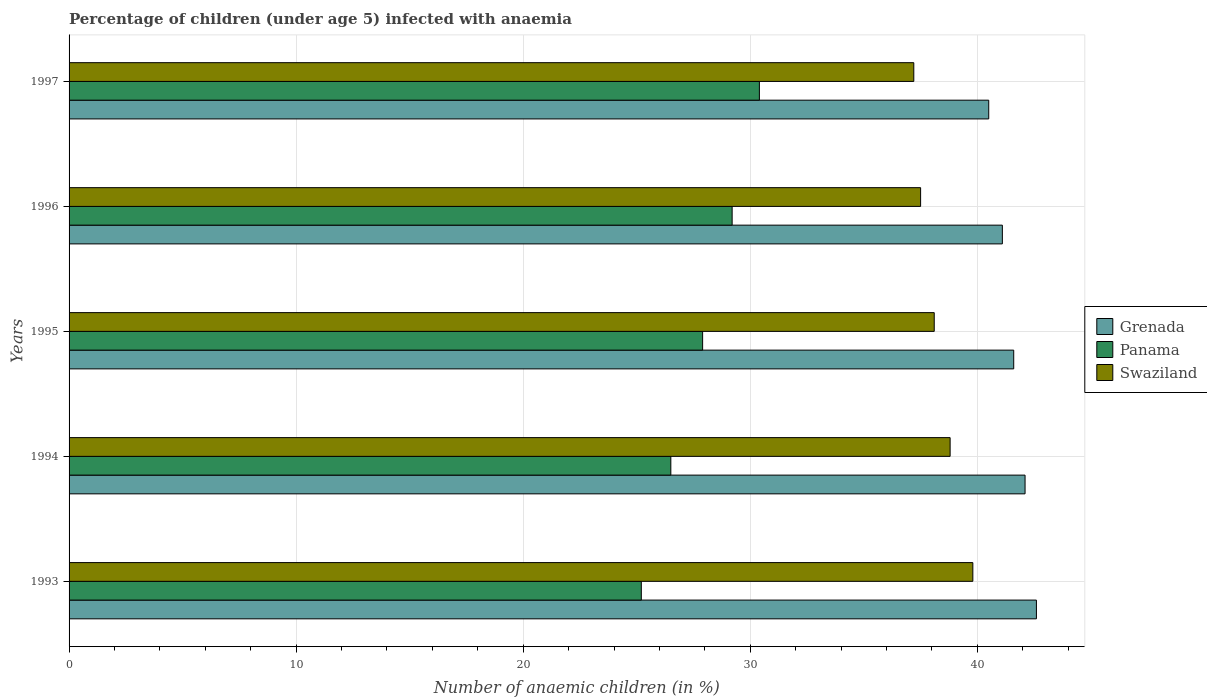How many different coloured bars are there?
Your answer should be very brief. 3. How many groups of bars are there?
Make the answer very short. 5. Are the number of bars on each tick of the Y-axis equal?
Give a very brief answer. Yes. How many bars are there on the 5th tick from the bottom?
Your answer should be very brief. 3. What is the label of the 3rd group of bars from the top?
Give a very brief answer. 1995. In how many cases, is the number of bars for a given year not equal to the number of legend labels?
Offer a terse response. 0. What is the percentage of children infected with anaemia in in Grenada in 1997?
Offer a terse response. 40.5. Across all years, what is the maximum percentage of children infected with anaemia in in Grenada?
Offer a very short reply. 42.6. Across all years, what is the minimum percentage of children infected with anaemia in in Grenada?
Your answer should be very brief. 40.5. In which year was the percentage of children infected with anaemia in in Swaziland minimum?
Ensure brevity in your answer.  1997. What is the total percentage of children infected with anaemia in in Grenada in the graph?
Provide a succinct answer. 207.9. What is the difference between the percentage of children infected with anaemia in in Panama in 1993 and that in 1995?
Offer a terse response. -2.7. What is the difference between the percentage of children infected with anaemia in in Swaziland in 1994 and the percentage of children infected with anaemia in in Panama in 1995?
Make the answer very short. 10.9. What is the average percentage of children infected with anaemia in in Grenada per year?
Give a very brief answer. 41.58. In the year 1994, what is the difference between the percentage of children infected with anaemia in in Grenada and percentage of children infected with anaemia in in Swaziland?
Give a very brief answer. 3.3. What is the ratio of the percentage of children infected with anaemia in in Swaziland in 1995 to that in 1996?
Your response must be concise. 1.02. Is the percentage of children infected with anaemia in in Grenada in 1994 less than that in 1995?
Keep it short and to the point. No. Is the difference between the percentage of children infected with anaemia in in Grenada in 1994 and 1996 greater than the difference between the percentage of children infected with anaemia in in Swaziland in 1994 and 1996?
Your answer should be compact. No. What is the difference between the highest and the lowest percentage of children infected with anaemia in in Grenada?
Make the answer very short. 2.1. What does the 2nd bar from the top in 1993 represents?
Your answer should be compact. Panama. What does the 3rd bar from the bottom in 1996 represents?
Keep it short and to the point. Swaziland. Is it the case that in every year, the sum of the percentage of children infected with anaemia in in Swaziland and percentage of children infected with anaemia in in Panama is greater than the percentage of children infected with anaemia in in Grenada?
Your answer should be compact. Yes. Are all the bars in the graph horizontal?
Keep it short and to the point. Yes. Does the graph contain any zero values?
Keep it short and to the point. No. Does the graph contain grids?
Your response must be concise. Yes. Where does the legend appear in the graph?
Your answer should be compact. Center right. How many legend labels are there?
Keep it short and to the point. 3. How are the legend labels stacked?
Provide a short and direct response. Vertical. What is the title of the graph?
Offer a terse response. Percentage of children (under age 5) infected with anaemia. Does "Tuvalu" appear as one of the legend labels in the graph?
Give a very brief answer. No. What is the label or title of the X-axis?
Offer a terse response. Number of anaemic children (in %). What is the label or title of the Y-axis?
Ensure brevity in your answer.  Years. What is the Number of anaemic children (in %) of Grenada in 1993?
Your answer should be very brief. 42.6. What is the Number of anaemic children (in %) of Panama in 1993?
Provide a succinct answer. 25.2. What is the Number of anaemic children (in %) in Swaziland in 1993?
Your answer should be very brief. 39.8. What is the Number of anaemic children (in %) in Grenada in 1994?
Make the answer very short. 42.1. What is the Number of anaemic children (in %) in Swaziland in 1994?
Give a very brief answer. 38.8. What is the Number of anaemic children (in %) in Grenada in 1995?
Provide a succinct answer. 41.6. What is the Number of anaemic children (in %) in Panama in 1995?
Ensure brevity in your answer.  27.9. What is the Number of anaemic children (in %) in Swaziland in 1995?
Make the answer very short. 38.1. What is the Number of anaemic children (in %) of Grenada in 1996?
Keep it short and to the point. 41.1. What is the Number of anaemic children (in %) in Panama in 1996?
Your response must be concise. 29.2. What is the Number of anaemic children (in %) in Swaziland in 1996?
Offer a terse response. 37.5. What is the Number of anaemic children (in %) of Grenada in 1997?
Provide a succinct answer. 40.5. What is the Number of anaemic children (in %) in Panama in 1997?
Keep it short and to the point. 30.4. What is the Number of anaemic children (in %) in Swaziland in 1997?
Offer a terse response. 37.2. Across all years, what is the maximum Number of anaemic children (in %) of Grenada?
Your answer should be very brief. 42.6. Across all years, what is the maximum Number of anaemic children (in %) in Panama?
Provide a short and direct response. 30.4. Across all years, what is the maximum Number of anaemic children (in %) in Swaziland?
Provide a short and direct response. 39.8. Across all years, what is the minimum Number of anaemic children (in %) of Grenada?
Your answer should be compact. 40.5. Across all years, what is the minimum Number of anaemic children (in %) of Panama?
Offer a very short reply. 25.2. Across all years, what is the minimum Number of anaemic children (in %) of Swaziland?
Offer a very short reply. 37.2. What is the total Number of anaemic children (in %) in Grenada in the graph?
Your response must be concise. 207.9. What is the total Number of anaemic children (in %) in Panama in the graph?
Offer a very short reply. 139.2. What is the total Number of anaemic children (in %) in Swaziland in the graph?
Your answer should be compact. 191.4. What is the difference between the Number of anaemic children (in %) of Grenada in 1993 and that in 1994?
Provide a short and direct response. 0.5. What is the difference between the Number of anaemic children (in %) of Panama in 1993 and that in 1994?
Offer a terse response. -1.3. What is the difference between the Number of anaemic children (in %) of Swaziland in 1993 and that in 1995?
Provide a succinct answer. 1.7. What is the difference between the Number of anaemic children (in %) in Grenada in 1993 and that in 1996?
Offer a very short reply. 1.5. What is the difference between the Number of anaemic children (in %) of Panama in 1993 and that in 1996?
Make the answer very short. -4. What is the difference between the Number of anaemic children (in %) of Panama in 1993 and that in 1997?
Your response must be concise. -5.2. What is the difference between the Number of anaemic children (in %) in Swaziland in 1993 and that in 1997?
Offer a terse response. 2.6. What is the difference between the Number of anaemic children (in %) of Grenada in 1994 and that in 1995?
Keep it short and to the point. 0.5. What is the difference between the Number of anaemic children (in %) in Swaziland in 1994 and that in 1995?
Make the answer very short. 0.7. What is the difference between the Number of anaemic children (in %) of Grenada in 1994 and that in 1997?
Make the answer very short. 1.6. What is the difference between the Number of anaemic children (in %) in Panama in 1994 and that in 1997?
Your answer should be very brief. -3.9. What is the difference between the Number of anaemic children (in %) of Panama in 1995 and that in 1996?
Give a very brief answer. -1.3. What is the difference between the Number of anaemic children (in %) of Grenada in 1995 and that in 1997?
Ensure brevity in your answer.  1.1. What is the difference between the Number of anaemic children (in %) of Swaziland in 1995 and that in 1997?
Ensure brevity in your answer.  0.9. What is the difference between the Number of anaemic children (in %) in Panama in 1996 and that in 1997?
Keep it short and to the point. -1.2. What is the difference between the Number of anaemic children (in %) in Grenada in 1993 and the Number of anaemic children (in %) in Swaziland in 1994?
Offer a very short reply. 3.8. What is the difference between the Number of anaemic children (in %) in Grenada in 1993 and the Number of anaemic children (in %) in Panama in 1995?
Keep it short and to the point. 14.7. What is the difference between the Number of anaemic children (in %) in Grenada in 1993 and the Number of anaemic children (in %) in Panama in 1996?
Give a very brief answer. 13.4. What is the difference between the Number of anaemic children (in %) in Grenada in 1993 and the Number of anaemic children (in %) in Swaziland in 1996?
Ensure brevity in your answer.  5.1. What is the difference between the Number of anaemic children (in %) of Panama in 1993 and the Number of anaemic children (in %) of Swaziland in 1996?
Ensure brevity in your answer.  -12.3. What is the difference between the Number of anaemic children (in %) of Grenada in 1993 and the Number of anaemic children (in %) of Swaziland in 1997?
Your answer should be compact. 5.4. What is the difference between the Number of anaemic children (in %) of Grenada in 1994 and the Number of anaemic children (in %) of Panama in 1995?
Offer a terse response. 14.2. What is the difference between the Number of anaemic children (in %) of Grenada in 1994 and the Number of anaemic children (in %) of Panama in 1997?
Offer a very short reply. 11.7. What is the difference between the Number of anaemic children (in %) of Grenada in 1994 and the Number of anaemic children (in %) of Swaziland in 1997?
Offer a terse response. 4.9. What is the difference between the Number of anaemic children (in %) of Grenada in 1995 and the Number of anaemic children (in %) of Swaziland in 1996?
Your answer should be very brief. 4.1. What is the difference between the Number of anaemic children (in %) in Grenada in 1995 and the Number of anaemic children (in %) in Swaziland in 1997?
Offer a very short reply. 4.4. What is the difference between the Number of anaemic children (in %) of Panama in 1996 and the Number of anaemic children (in %) of Swaziland in 1997?
Provide a succinct answer. -8. What is the average Number of anaemic children (in %) of Grenada per year?
Ensure brevity in your answer.  41.58. What is the average Number of anaemic children (in %) in Panama per year?
Offer a terse response. 27.84. What is the average Number of anaemic children (in %) in Swaziland per year?
Your response must be concise. 38.28. In the year 1993, what is the difference between the Number of anaemic children (in %) of Grenada and Number of anaemic children (in %) of Panama?
Your response must be concise. 17.4. In the year 1993, what is the difference between the Number of anaemic children (in %) of Grenada and Number of anaemic children (in %) of Swaziland?
Ensure brevity in your answer.  2.8. In the year 1993, what is the difference between the Number of anaemic children (in %) in Panama and Number of anaemic children (in %) in Swaziland?
Ensure brevity in your answer.  -14.6. In the year 1994, what is the difference between the Number of anaemic children (in %) of Grenada and Number of anaemic children (in %) of Swaziland?
Make the answer very short. 3.3. In the year 1994, what is the difference between the Number of anaemic children (in %) in Panama and Number of anaemic children (in %) in Swaziland?
Your answer should be compact. -12.3. In the year 1996, what is the difference between the Number of anaemic children (in %) of Grenada and Number of anaemic children (in %) of Swaziland?
Your answer should be compact. 3.6. In the year 1996, what is the difference between the Number of anaemic children (in %) in Panama and Number of anaemic children (in %) in Swaziland?
Offer a terse response. -8.3. In the year 1997, what is the difference between the Number of anaemic children (in %) in Grenada and Number of anaemic children (in %) in Panama?
Provide a succinct answer. 10.1. What is the ratio of the Number of anaemic children (in %) of Grenada in 1993 to that in 1994?
Make the answer very short. 1.01. What is the ratio of the Number of anaemic children (in %) of Panama in 1993 to that in 1994?
Your response must be concise. 0.95. What is the ratio of the Number of anaemic children (in %) in Swaziland in 1993 to that in 1994?
Offer a very short reply. 1.03. What is the ratio of the Number of anaemic children (in %) of Grenada in 1993 to that in 1995?
Your answer should be compact. 1.02. What is the ratio of the Number of anaemic children (in %) in Panama in 1993 to that in 1995?
Provide a succinct answer. 0.9. What is the ratio of the Number of anaemic children (in %) in Swaziland in 1993 to that in 1995?
Offer a terse response. 1.04. What is the ratio of the Number of anaemic children (in %) of Grenada in 1993 to that in 1996?
Give a very brief answer. 1.04. What is the ratio of the Number of anaemic children (in %) in Panama in 1993 to that in 1996?
Your answer should be very brief. 0.86. What is the ratio of the Number of anaemic children (in %) of Swaziland in 1993 to that in 1996?
Your answer should be very brief. 1.06. What is the ratio of the Number of anaemic children (in %) in Grenada in 1993 to that in 1997?
Ensure brevity in your answer.  1.05. What is the ratio of the Number of anaemic children (in %) of Panama in 1993 to that in 1997?
Offer a terse response. 0.83. What is the ratio of the Number of anaemic children (in %) of Swaziland in 1993 to that in 1997?
Ensure brevity in your answer.  1.07. What is the ratio of the Number of anaemic children (in %) of Grenada in 1994 to that in 1995?
Make the answer very short. 1.01. What is the ratio of the Number of anaemic children (in %) in Panama in 1994 to that in 1995?
Your response must be concise. 0.95. What is the ratio of the Number of anaemic children (in %) in Swaziland in 1994 to that in 1995?
Offer a very short reply. 1.02. What is the ratio of the Number of anaemic children (in %) in Grenada in 1994 to that in 1996?
Make the answer very short. 1.02. What is the ratio of the Number of anaemic children (in %) in Panama in 1994 to that in 1996?
Ensure brevity in your answer.  0.91. What is the ratio of the Number of anaemic children (in %) in Swaziland in 1994 to that in 1996?
Make the answer very short. 1.03. What is the ratio of the Number of anaemic children (in %) of Grenada in 1994 to that in 1997?
Ensure brevity in your answer.  1.04. What is the ratio of the Number of anaemic children (in %) of Panama in 1994 to that in 1997?
Make the answer very short. 0.87. What is the ratio of the Number of anaemic children (in %) of Swaziland in 1994 to that in 1997?
Provide a succinct answer. 1.04. What is the ratio of the Number of anaemic children (in %) of Grenada in 1995 to that in 1996?
Make the answer very short. 1.01. What is the ratio of the Number of anaemic children (in %) of Panama in 1995 to that in 1996?
Give a very brief answer. 0.96. What is the ratio of the Number of anaemic children (in %) in Grenada in 1995 to that in 1997?
Offer a very short reply. 1.03. What is the ratio of the Number of anaemic children (in %) of Panama in 1995 to that in 1997?
Provide a succinct answer. 0.92. What is the ratio of the Number of anaemic children (in %) in Swaziland in 1995 to that in 1997?
Provide a succinct answer. 1.02. What is the ratio of the Number of anaemic children (in %) of Grenada in 1996 to that in 1997?
Offer a terse response. 1.01. What is the ratio of the Number of anaemic children (in %) in Panama in 1996 to that in 1997?
Give a very brief answer. 0.96. What is the difference between the highest and the second highest Number of anaemic children (in %) in Grenada?
Provide a short and direct response. 0.5. What is the difference between the highest and the second highest Number of anaemic children (in %) in Swaziland?
Keep it short and to the point. 1. 